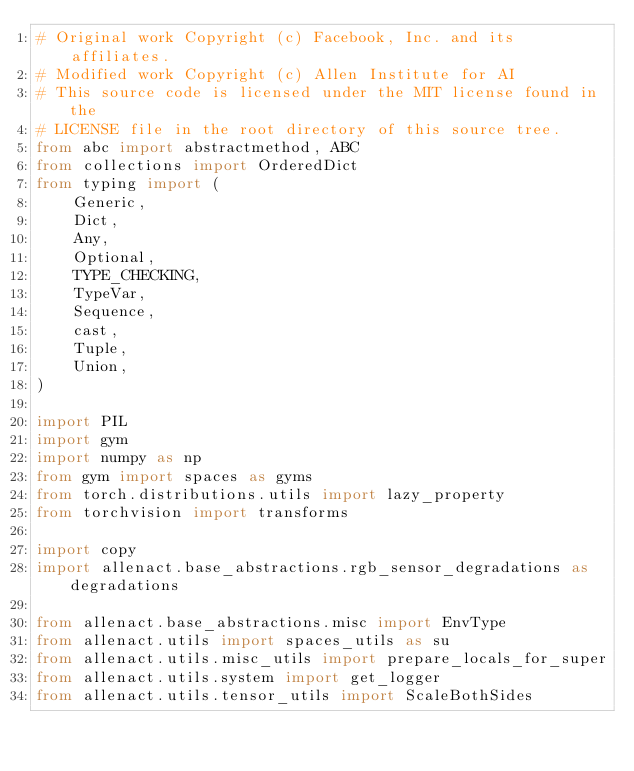Convert code to text. <code><loc_0><loc_0><loc_500><loc_500><_Python_># Original work Copyright (c) Facebook, Inc. and its affiliates.
# Modified work Copyright (c) Allen Institute for AI
# This source code is licensed under the MIT license found in the
# LICENSE file in the root directory of this source tree.
from abc import abstractmethod, ABC
from collections import OrderedDict
from typing import (
    Generic,
    Dict,
    Any,
    Optional,
    TYPE_CHECKING,
    TypeVar,
    Sequence,
    cast,
    Tuple,
    Union,
)

import PIL
import gym
import numpy as np
from gym import spaces as gyms
from torch.distributions.utils import lazy_property
from torchvision import transforms

import copy
import allenact.base_abstractions.rgb_sensor_degradations as degradations

from allenact.base_abstractions.misc import EnvType
from allenact.utils import spaces_utils as su
from allenact.utils.misc_utils import prepare_locals_for_super
from allenact.utils.system import get_logger
from allenact.utils.tensor_utils import ScaleBothSides
</code> 